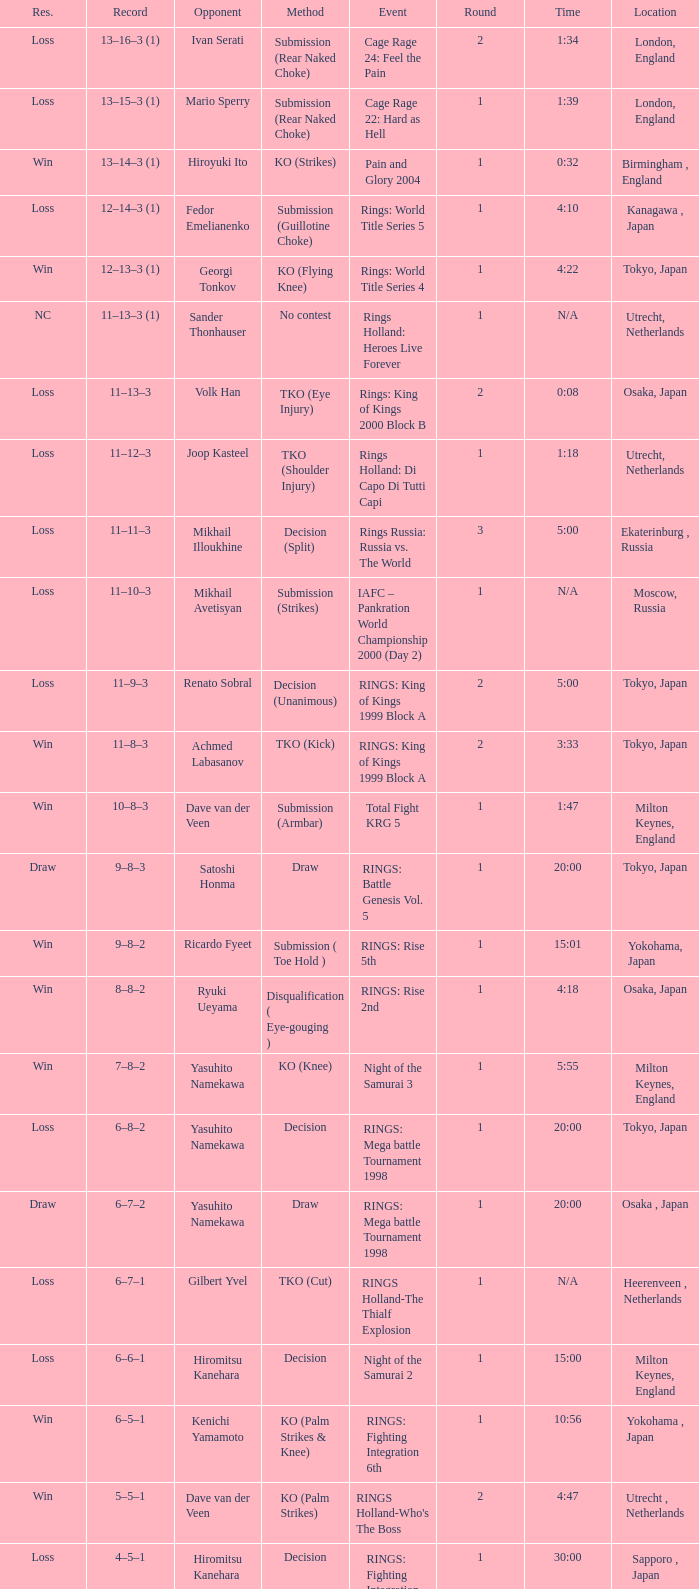Help me parse the entirety of this table. {'header': ['Res.', 'Record', 'Opponent', 'Method', 'Event', 'Round', 'Time', 'Location'], 'rows': [['Loss', '13–16–3 (1)', 'Ivan Serati', 'Submission (Rear Naked Choke)', 'Cage Rage 24: Feel the Pain', '2', '1:34', 'London, England'], ['Loss', '13–15–3 (1)', 'Mario Sperry', 'Submission (Rear Naked Choke)', 'Cage Rage 22: Hard as Hell', '1', '1:39', 'London, England'], ['Win', '13–14–3 (1)', 'Hiroyuki Ito', 'KO (Strikes)', 'Pain and Glory 2004', '1', '0:32', 'Birmingham , England'], ['Loss', '12–14–3 (1)', 'Fedor Emelianenko', 'Submission (Guillotine Choke)', 'Rings: World Title Series 5', '1', '4:10', 'Kanagawa , Japan'], ['Win', '12–13–3 (1)', 'Georgi Tonkov', 'KO (Flying Knee)', 'Rings: World Title Series 4', '1', '4:22', 'Tokyo, Japan'], ['NC', '11–13–3 (1)', 'Sander Thonhauser', 'No contest', 'Rings Holland: Heroes Live Forever', '1', 'N/A', 'Utrecht, Netherlands'], ['Loss', '11–13–3', 'Volk Han', 'TKO (Eye Injury)', 'Rings: King of Kings 2000 Block B', '2', '0:08', 'Osaka, Japan'], ['Loss', '11–12–3', 'Joop Kasteel', 'TKO (Shoulder Injury)', 'Rings Holland: Di Capo Di Tutti Capi', '1', '1:18', 'Utrecht, Netherlands'], ['Loss', '11–11–3', 'Mikhail Illoukhine', 'Decision (Split)', 'Rings Russia: Russia vs. The World', '3', '5:00', 'Ekaterinburg , Russia'], ['Loss', '11–10–3', 'Mikhail Avetisyan', 'Submission (Strikes)', 'IAFC – Pankration World Championship 2000 (Day 2)', '1', 'N/A', 'Moscow, Russia'], ['Loss', '11–9–3', 'Renato Sobral', 'Decision (Unanimous)', 'RINGS: King of Kings 1999 Block A', '2', '5:00', 'Tokyo, Japan'], ['Win', '11–8–3', 'Achmed Labasanov', 'TKO (Kick)', 'RINGS: King of Kings 1999 Block A', '2', '3:33', 'Tokyo, Japan'], ['Win', '10–8–3', 'Dave van der Veen', 'Submission (Armbar)', 'Total Fight KRG 5', '1', '1:47', 'Milton Keynes, England'], ['Draw', '9–8–3', 'Satoshi Honma', 'Draw', 'RINGS: Battle Genesis Vol. 5', '1', '20:00', 'Tokyo, Japan'], ['Win', '9–8–2', 'Ricardo Fyeet', 'Submission ( Toe Hold )', 'RINGS: Rise 5th', '1', '15:01', 'Yokohama, Japan'], ['Win', '8–8–2', 'Ryuki Ueyama', 'Disqualification ( Eye-gouging )', 'RINGS: Rise 2nd', '1', '4:18', 'Osaka, Japan'], ['Win', '7–8–2', 'Yasuhito Namekawa', 'KO (Knee)', 'Night of the Samurai 3', '1', '5:55', 'Milton Keynes, England'], ['Loss', '6–8–2', 'Yasuhito Namekawa', 'Decision', 'RINGS: Mega battle Tournament 1998', '1', '20:00', 'Tokyo, Japan'], ['Draw', '6–7–2', 'Yasuhito Namekawa', 'Draw', 'RINGS: Mega battle Tournament 1998', '1', '20:00', 'Osaka , Japan'], ['Loss', '6–7–1', 'Gilbert Yvel', 'TKO (Cut)', 'RINGS Holland-The Thialf Explosion', '1', 'N/A', 'Heerenveen , Netherlands'], ['Loss', '6–6–1', 'Hiromitsu Kanehara', 'Decision', 'Night of the Samurai 2', '1', '15:00', 'Milton Keynes, England'], ['Win', '6–5–1', 'Kenichi Yamamoto', 'KO (Palm Strikes & Knee)', 'RINGS: Fighting Integration 6th', '1', '10:56', 'Yokohama , Japan'], ['Win', '5–5–1', 'Dave van der Veen', 'KO (Palm Strikes)', "RINGS Holland-Who's The Boss", '2', '4:47', 'Utrecht , Netherlands'], ['Loss', '4–5–1', 'Hiromitsu Kanehara', 'Decision', 'RINGS: Fighting Integration 3rd', '1', '30:00', 'Sapporo , Japan'], ['Win', '4–4–1', 'Sander Thonhauser', 'Submission ( Armbar )', 'Night of the Samurai 1', '1', '0:55', 'Milton Keynes, England'], ['Loss', '3–4–1', 'Joop Kasteel', 'Submission ( Headlock )', 'RINGS: Mega Battle Tournament 1997', '1', '8:55', 'Tokyo, Japan'], ['Win', '3–3–1', 'Peter Dijkman', 'Submission ( Rear Naked Choke )', 'Total Fight Night', '1', '4:46', 'Milton Keynes, England'], ['Loss', '2–3–1', 'Masayuki Naruse', 'Submission ( Shoulder Necklock )', 'RINGS: Fighting Extension Vol. 4', '1', '12:58', 'Tokyo, Japan'], ['Win', '2–2–1', 'Sean McCully', 'Submission (Guillotine Choke)', 'RINGS: Battle Genesis Vol. 1', '1', '3:59', 'Tokyo, Japan'], ['Loss', '1–2–1', 'Hans Nijman', 'Submission ( Guillotine Choke )', 'RINGS Holland-The Final Challenge', '2', '0:51', 'Amsterdam, Netherlands'], ['Loss', '1–1–1', 'Cees Bezems', 'TKO (Cut)', 'IMA – Battle of Styles', '1', 'N/A', 'Amsterdam, Netherlands'], ['Draw', '1–0–1', 'Andre Mannaart', 'Draw', 'RINGS Holland-Kings of Martial Arts', '2', '5:00', 'Amsterdam , Netherlands'], ['Win', '1–0–0', 'Boston Jones', 'TKO (Cut)', 'Fighting Arts Gala', '2', '2:30', 'Milton Keynes , England']]} Which happening had a rival of yasuhito namekawa with a resolution method? RINGS: Mega battle Tournament 1998. 